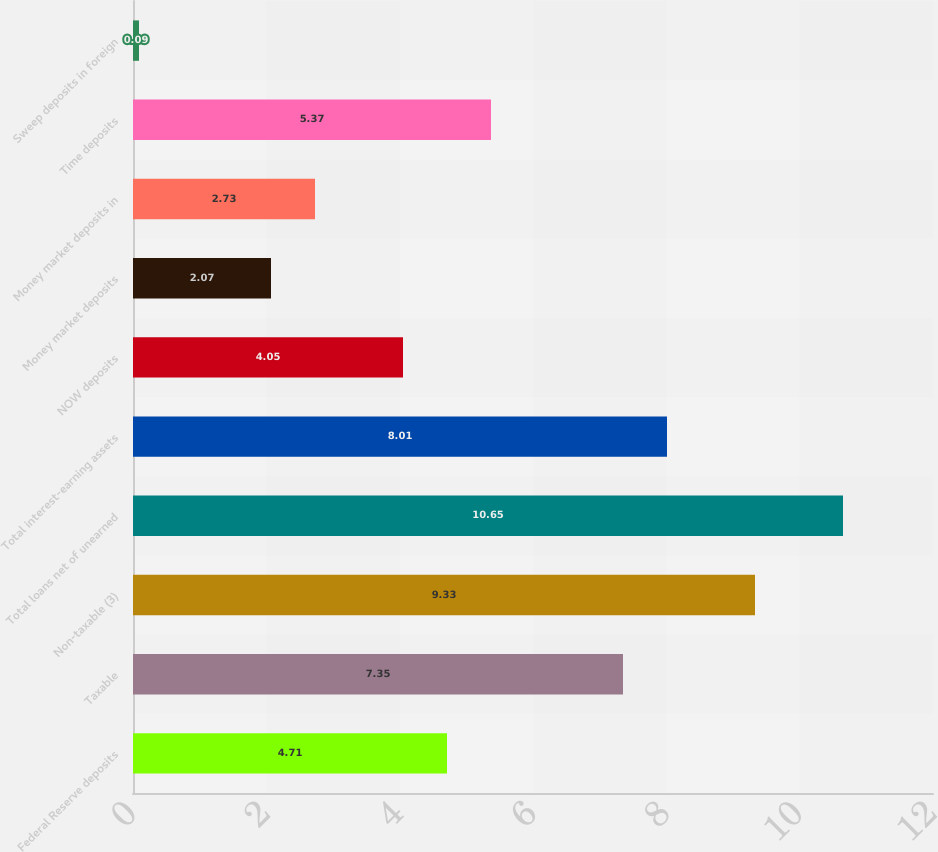Convert chart. <chart><loc_0><loc_0><loc_500><loc_500><bar_chart><fcel>Federal Reserve deposits<fcel>Taxable<fcel>Non-taxable (3)<fcel>Total loans net of unearned<fcel>Total interest-earning assets<fcel>NOW deposits<fcel>Money market deposits<fcel>Money market deposits in<fcel>Time deposits<fcel>Sweep deposits in foreign<nl><fcel>4.71<fcel>7.35<fcel>9.33<fcel>10.65<fcel>8.01<fcel>4.05<fcel>2.07<fcel>2.73<fcel>5.37<fcel>0.09<nl></chart> 